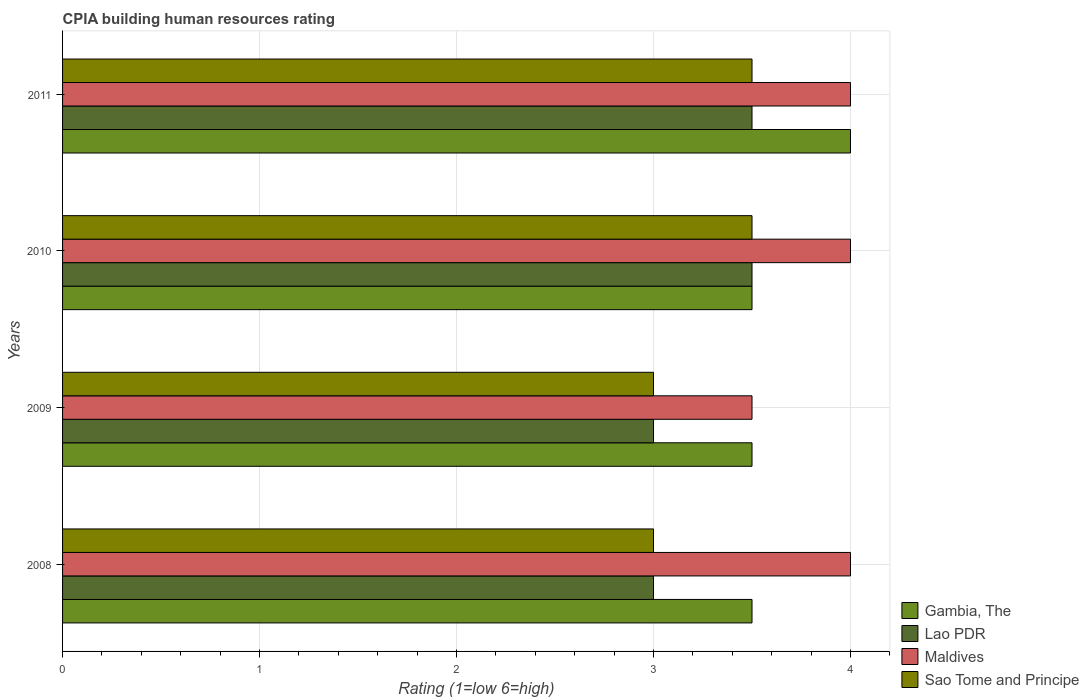How many different coloured bars are there?
Ensure brevity in your answer.  4. Are the number of bars on each tick of the Y-axis equal?
Your answer should be very brief. Yes. In which year was the CPIA rating in Lao PDR minimum?
Provide a succinct answer. 2008. What is the difference between the CPIA rating in Gambia, The in 2011 and the CPIA rating in Sao Tome and Principe in 2008?
Provide a short and direct response. 1. What is the average CPIA rating in Sao Tome and Principe per year?
Make the answer very short. 3.25. In how many years, is the CPIA rating in Lao PDR greater than 3 ?
Keep it short and to the point. 2. What is the ratio of the CPIA rating in Lao PDR in 2008 to that in 2010?
Your answer should be very brief. 0.86. Is the CPIA rating in Sao Tome and Principe in 2008 less than that in 2009?
Offer a terse response. No. Is the difference between the CPIA rating in Lao PDR in 2008 and 2010 greater than the difference between the CPIA rating in Gambia, The in 2008 and 2010?
Provide a succinct answer. No. What is the difference between the highest and the lowest CPIA rating in Maldives?
Your response must be concise. 0.5. Is the sum of the CPIA rating in Gambia, The in 2009 and 2011 greater than the maximum CPIA rating in Lao PDR across all years?
Ensure brevity in your answer.  Yes. What does the 2nd bar from the top in 2009 represents?
Give a very brief answer. Maldives. What does the 1st bar from the bottom in 2011 represents?
Your response must be concise. Gambia, The. Is it the case that in every year, the sum of the CPIA rating in Sao Tome and Principe and CPIA rating in Maldives is greater than the CPIA rating in Gambia, The?
Your response must be concise. Yes. How many years are there in the graph?
Provide a succinct answer. 4. What is the difference between two consecutive major ticks on the X-axis?
Ensure brevity in your answer.  1. Are the values on the major ticks of X-axis written in scientific E-notation?
Your answer should be very brief. No. Does the graph contain any zero values?
Provide a succinct answer. No. Does the graph contain grids?
Offer a very short reply. Yes. Where does the legend appear in the graph?
Your response must be concise. Bottom right. How are the legend labels stacked?
Your response must be concise. Vertical. What is the title of the graph?
Make the answer very short. CPIA building human resources rating. Does "United States" appear as one of the legend labels in the graph?
Offer a very short reply. No. What is the label or title of the X-axis?
Your response must be concise. Rating (1=low 6=high). What is the label or title of the Y-axis?
Offer a very short reply. Years. What is the Rating (1=low 6=high) in Gambia, The in 2008?
Offer a terse response. 3.5. What is the Rating (1=low 6=high) of Maldives in 2008?
Offer a terse response. 4. What is the Rating (1=low 6=high) in Sao Tome and Principe in 2008?
Provide a short and direct response. 3. What is the Rating (1=low 6=high) of Gambia, The in 2009?
Offer a terse response. 3.5. What is the Rating (1=low 6=high) of Maldives in 2009?
Provide a short and direct response. 3.5. What is the Rating (1=low 6=high) of Gambia, The in 2010?
Give a very brief answer. 3.5. What is the Rating (1=low 6=high) of Lao PDR in 2010?
Provide a short and direct response. 3.5. What is the Rating (1=low 6=high) of Maldives in 2011?
Offer a terse response. 4. What is the Rating (1=low 6=high) of Sao Tome and Principe in 2011?
Provide a short and direct response. 3.5. Across all years, what is the maximum Rating (1=low 6=high) in Gambia, The?
Offer a very short reply. 4. Across all years, what is the minimum Rating (1=low 6=high) of Lao PDR?
Your answer should be very brief. 3. Across all years, what is the minimum Rating (1=low 6=high) in Maldives?
Your answer should be compact. 3.5. Across all years, what is the minimum Rating (1=low 6=high) of Sao Tome and Principe?
Provide a short and direct response. 3. What is the total Rating (1=low 6=high) in Gambia, The in the graph?
Your answer should be compact. 14.5. What is the total Rating (1=low 6=high) of Maldives in the graph?
Provide a succinct answer. 15.5. What is the difference between the Rating (1=low 6=high) in Gambia, The in 2008 and that in 2009?
Provide a short and direct response. 0. What is the difference between the Rating (1=low 6=high) of Lao PDR in 2008 and that in 2010?
Your response must be concise. -0.5. What is the difference between the Rating (1=low 6=high) in Gambia, The in 2008 and that in 2011?
Make the answer very short. -0.5. What is the difference between the Rating (1=low 6=high) in Lao PDR in 2008 and that in 2011?
Your answer should be compact. -0.5. What is the difference between the Rating (1=low 6=high) in Maldives in 2008 and that in 2011?
Ensure brevity in your answer.  0. What is the difference between the Rating (1=low 6=high) in Gambia, The in 2009 and that in 2010?
Provide a succinct answer. 0. What is the difference between the Rating (1=low 6=high) of Maldives in 2009 and that in 2010?
Your response must be concise. -0.5. What is the difference between the Rating (1=low 6=high) in Gambia, The in 2009 and that in 2011?
Keep it short and to the point. -0.5. What is the difference between the Rating (1=low 6=high) of Lao PDR in 2009 and that in 2011?
Your answer should be compact. -0.5. What is the difference between the Rating (1=low 6=high) of Maldives in 2009 and that in 2011?
Provide a short and direct response. -0.5. What is the difference between the Rating (1=low 6=high) in Sao Tome and Principe in 2009 and that in 2011?
Provide a succinct answer. -0.5. What is the difference between the Rating (1=low 6=high) of Gambia, The in 2010 and that in 2011?
Give a very brief answer. -0.5. What is the difference between the Rating (1=low 6=high) of Lao PDR in 2010 and that in 2011?
Make the answer very short. 0. What is the difference between the Rating (1=low 6=high) of Gambia, The in 2008 and the Rating (1=low 6=high) of Maldives in 2009?
Your answer should be compact. 0. What is the difference between the Rating (1=low 6=high) of Maldives in 2008 and the Rating (1=low 6=high) of Sao Tome and Principe in 2009?
Give a very brief answer. 1. What is the difference between the Rating (1=low 6=high) in Gambia, The in 2008 and the Rating (1=low 6=high) in Lao PDR in 2010?
Your answer should be very brief. 0. What is the difference between the Rating (1=low 6=high) of Gambia, The in 2008 and the Rating (1=low 6=high) of Maldives in 2010?
Offer a very short reply. -0.5. What is the difference between the Rating (1=low 6=high) of Lao PDR in 2008 and the Rating (1=low 6=high) of Maldives in 2010?
Provide a short and direct response. -1. What is the difference between the Rating (1=low 6=high) of Maldives in 2008 and the Rating (1=low 6=high) of Sao Tome and Principe in 2010?
Ensure brevity in your answer.  0.5. What is the difference between the Rating (1=low 6=high) in Gambia, The in 2008 and the Rating (1=low 6=high) in Lao PDR in 2011?
Your answer should be very brief. 0. What is the difference between the Rating (1=low 6=high) in Gambia, The in 2008 and the Rating (1=low 6=high) in Sao Tome and Principe in 2011?
Ensure brevity in your answer.  0. What is the difference between the Rating (1=low 6=high) in Lao PDR in 2008 and the Rating (1=low 6=high) in Sao Tome and Principe in 2011?
Your answer should be very brief. -0.5. What is the difference between the Rating (1=low 6=high) in Maldives in 2008 and the Rating (1=low 6=high) in Sao Tome and Principe in 2011?
Keep it short and to the point. 0.5. What is the difference between the Rating (1=low 6=high) of Gambia, The in 2009 and the Rating (1=low 6=high) of Maldives in 2010?
Give a very brief answer. -0.5. What is the difference between the Rating (1=low 6=high) of Gambia, The in 2009 and the Rating (1=low 6=high) of Sao Tome and Principe in 2010?
Your answer should be compact. 0. What is the difference between the Rating (1=low 6=high) in Lao PDR in 2009 and the Rating (1=low 6=high) in Maldives in 2010?
Offer a very short reply. -1. What is the difference between the Rating (1=low 6=high) of Lao PDR in 2009 and the Rating (1=low 6=high) of Sao Tome and Principe in 2010?
Make the answer very short. -0.5. What is the difference between the Rating (1=low 6=high) of Gambia, The in 2009 and the Rating (1=low 6=high) of Lao PDR in 2011?
Offer a very short reply. 0. What is the difference between the Rating (1=low 6=high) in Gambia, The in 2009 and the Rating (1=low 6=high) in Sao Tome and Principe in 2011?
Make the answer very short. 0. What is the difference between the Rating (1=low 6=high) in Lao PDR in 2009 and the Rating (1=low 6=high) in Maldives in 2011?
Keep it short and to the point. -1. What is the difference between the Rating (1=low 6=high) of Lao PDR in 2009 and the Rating (1=low 6=high) of Sao Tome and Principe in 2011?
Provide a short and direct response. -0.5. What is the difference between the Rating (1=low 6=high) in Gambia, The in 2010 and the Rating (1=low 6=high) in Lao PDR in 2011?
Make the answer very short. 0. What is the difference between the Rating (1=low 6=high) in Lao PDR in 2010 and the Rating (1=low 6=high) in Maldives in 2011?
Your answer should be very brief. -0.5. What is the average Rating (1=low 6=high) in Gambia, The per year?
Your answer should be compact. 3.62. What is the average Rating (1=low 6=high) in Maldives per year?
Offer a terse response. 3.88. In the year 2008, what is the difference between the Rating (1=low 6=high) of Gambia, The and Rating (1=low 6=high) of Lao PDR?
Offer a terse response. 0.5. In the year 2008, what is the difference between the Rating (1=low 6=high) in Gambia, The and Rating (1=low 6=high) in Maldives?
Your response must be concise. -0.5. In the year 2008, what is the difference between the Rating (1=low 6=high) of Lao PDR and Rating (1=low 6=high) of Maldives?
Offer a terse response. -1. In the year 2008, what is the difference between the Rating (1=low 6=high) in Lao PDR and Rating (1=low 6=high) in Sao Tome and Principe?
Offer a terse response. 0. In the year 2008, what is the difference between the Rating (1=low 6=high) of Maldives and Rating (1=low 6=high) of Sao Tome and Principe?
Provide a succinct answer. 1. In the year 2009, what is the difference between the Rating (1=low 6=high) of Gambia, The and Rating (1=low 6=high) of Lao PDR?
Give a very brief answer. 0.5. In the year 2009, what is the difference between the Rating (1=low 6=high) of Gambia, The and Rating (1=low 6=high) of Sao Tome and Principe?
Make the answer very short. 0.5. In the year 2009, what is the difference between the Rating (1=low 6=high) of Lao PDR and Rating (1=low 6=high) of Maldives?
Give a very brief answer. -0.5. In the year 2009, what is the difference between the Rating (1=low 6=high) of Maldives and Rating (1=low 6=high) of Sao Tome and Principe?
Your answer should be compact. 0.5. In the year 2010, what is the difference between the Rating (1=low 6=high) of Maldives and Rating (1=low 6=high) of Sao Tome and Principe?
Offer a terse response. 0.5. In the year 2011, what is the difference between the Rating (1=low 6=high) of Gambia, The and Rating (1=low 6=high) of Lao PDR?
Provide a short and direct response. 0.5. In the year 2011, what is the difference between the Rating (1=low 6=high) of Gambia, The and Rating (1=low 6=high) of Sao Tome and Principe?
Your answer should be very brief. 0.5. In the year 2011, what is the difference between the Rating (1=low 6=high) in Lao PDR and Rating (1=low 6=high) in Sao Tome and Principe?
Offer a terse response. 0. In the year 2011, what is the difference between the Rating (1=low 6=high) in Maldives and Rating (1=low 6=high) in Sao Tome and Principe?
Give a very brief answer. 0.5. What is the ratio of the Rating (1=low 6=high) in Gambia, The in 2008 to that in 2009?
Give a very brief answer. 1. What is the ratio of the Rating (1=low 6=high) in Lao PDR in 2008 to that in 2009?
Provide a succinct answer. 1. What is the ratio of the Rating (1=low 6=high) of Sao Tome and Principe in 2008 to that in 2009?
Offer a terse response. 1. What is the ratio of the Rating (1=low 6=high) in Gambia, The in 2008 to that in 2010?
Your answer should be compact. 1. What is the ratio of the Rating (1=low 6=high) in Maldives in 2008 to that in 2010?
Your answer should be very brief. 1. What is the ratio of the Rating (1=low 6=high) of Gambia, The in 2008 to that in 2011?
Provide a succinct answer. 0.88. What is the ratio of the Rating (1=low 6=high) in Maldives in 2008 to that in 2011?
Your response must be concise. 1. What is the ratio of the Rating (1=low 6=high) of Gambia, The in 2009 to that in 2010?
Offer a very short reply. 1. What is the ratio of the Rating (1=low 6=high) of Sao Tome and Principe in 2009 to that in 2010?
Provide a succinct answer. 0.86. What is the ratio of the Rating (1=low 6=high) of Maldives in 2009 to that in 2011?
Give a very brief answer. 0.88. What is the ratio of the Rating (1=low 6=high) of Gambia, The in 2010 to that in 2011?
Make the answer very short. 0.88. What is the ratio of the Rating (1=low 6=high) in Lao PDR in 2010 to that in 2011?
Provide a succinct answer. 1. What is the ratio of the Rating (1=low 6=high) in Maldives in 2010 to that in 2011?
Provide a short and direct response. 1. What is the ratio of the Rating (1=low 6=high) in Sao Tome and Principe in 2010 to that in 2011?
Offer a very short reply. 1. What is the difference between the highest and the second highest Rating (1=low 6=high) in Maldives?
Provide a succinct answer. 0. What is the difference between the highest and the lowest Rating (1=low 6=high) of Sao Tome and Principe?
Your response must be concise. 0.5. 